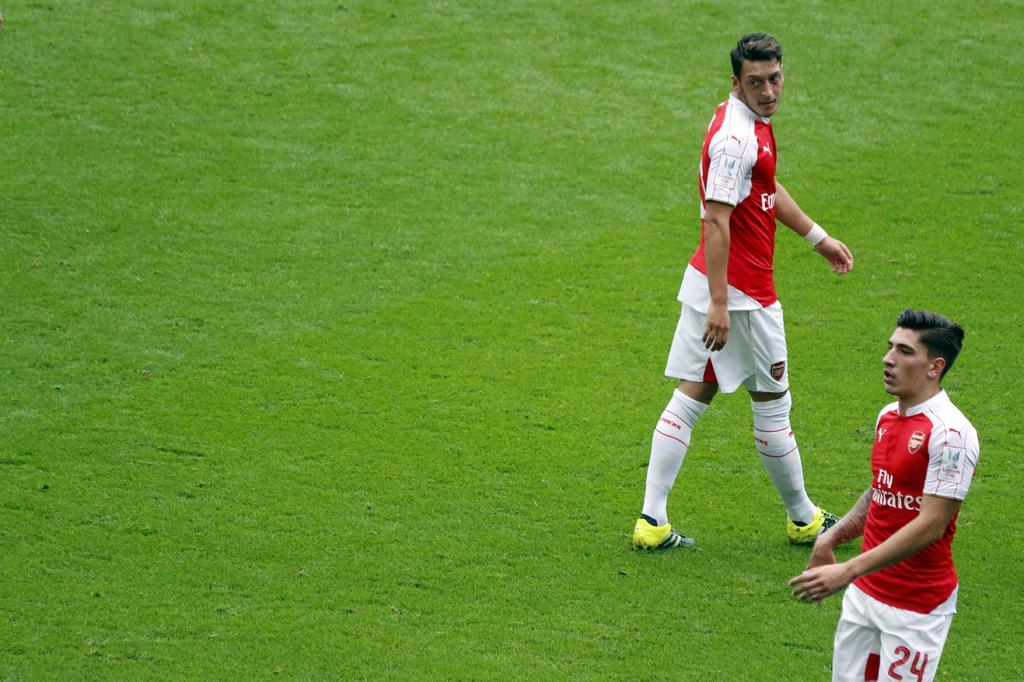Describe this image in one or two sentences. In this image I can see two persons wearing red and white color jersey are standing and I can see some grass on the ground. 